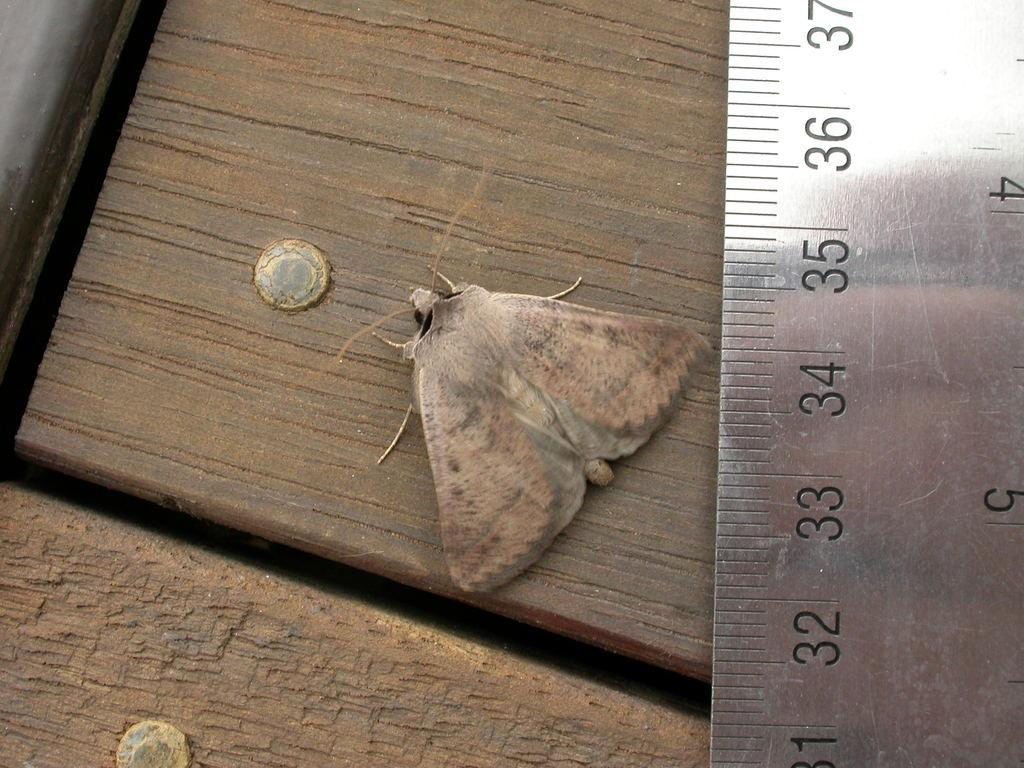<image>
Offer a succinct explanation of the picture presented. A silver ruler with numbers 31-37 on it is next to a moth. 